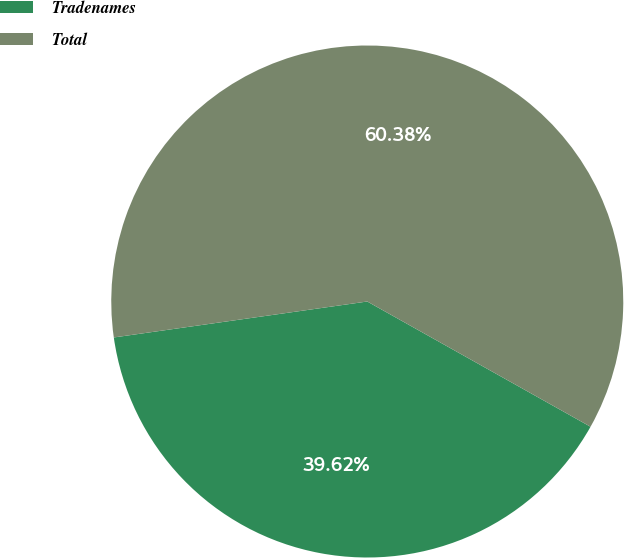Convert chart to OTSL. <chart><loc_0><loc_0><loc_500><loc_500><pie_chart><fcel>Tradenames<fcel>Total<nl><fcel>39.62%<fcel>60.38%<nl></chart> 